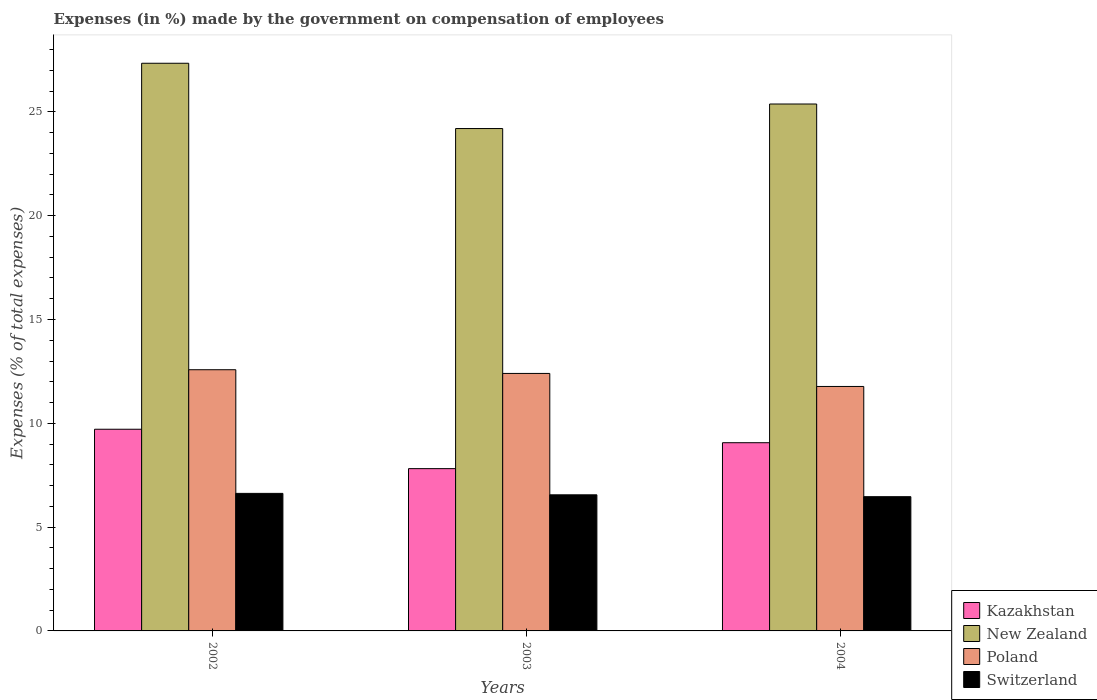Are the number of bars per tick equal to the number of legend labels?
Offer a terse response. Yes. Are the number of bars on each tick of the X-axis equal?
Ensure brevity in your answer.  Yes. How many bars are there on the 1st tick from the right?
Your answer should be very brief. 4. In how many cases, is the number of bars for a given year not equal to the number of legend labels?
Ensure brevity in your answer.  0. What is the percentage of expenses made by the government on compensation of employees in New Zealand in 2002?
Your response must be concise. 27.34. Across all years, what is the maximum percentage of expenses made by the government on compensation of employees in Switzerland?
Your answer should be compact. 6.62. Across all years, what is the minimum percentage of expenses made by the government on compensation of employees in Poland?
Your answer should be compact. 11.77. What is the total percentage of expenses made by the government on compensation of employees in New Zealand in the graph?
Offer a very short reply. 76.92. What is the difference between the percentage of expenses made by the government on compensation of employees in Kazakhstan in 2003 and that in 2004?
Make the answer very short. -1.25. What is the difference between the percentage of expenses made by the government on compensation of employees in Poland in 2002 and the percentage of expenses made by the government on compensation of employees in Kazakhstan in 2004?
Ensure brevity in your answer.  3.52. What is the average percentage of expenses made by the government on compensation of employees in Kazakhstan per year?
Provide a succinct answer. 8.87. In the year 2002, what is the difference between the percentage of expenses made by the government on compensation of employees in Kazakhstan and percentage of expenses made by the government on compensation of employees in Switzerland?
Make the answer very short. 3.09. In how many years, is the percentage of expenses made by the government on compensation of employees in Kazakhstan greater than 24 %?
Provide a succinct answer. 0. What is the ratio of the percentage of expenses made by the government on compensation of employees in Switzerland in 2002 to that in 2003?
Your response must be concise. 1.01. Is the difference between the percentage of expenses made by the government on compensation of employees in Kazakhstan in 2003 and 2004 greater than the difference between the percentage of expenses made by the government on compensation of employees in Switzerland in 2003 and 2004?
Offer a terse response. No. What is the difference between the highest and the second highest percentage of expenses made by the government on compensation of employees in Poland?
Provide a short and direct response. 0.18. What is the difference between the highest and the lowest percentage of expenses made by the government on compensation of employees in Kazakhstan?
Make the answer very short. 1.9. Is the sum of the percentage of expenses made by the government on compensation of employees in Kazakhstan in 2002 and 2003 greater than the maximum percentage of expenses made by the government on compensation of employees in Switzerland across all years?
Provide a succinct answer. Yes. What does the 1st bar from the left in 2002 represents?
Ensure brevity in your answer.  Kazakhstan. What does the 1st bar from the right in 2002 represents?
Ensure brevity in your answer.  Switzerland. Is it the case that in every year, the sum of the percentage of expenses made by the government on compensation of employees in New Zealand and percentage of expenses made by the government on compensation of employees in Kazakhstan is greater than the percentage of expenses made by the government on compensation of employees in Poland?
Give a very brief answer. Yes. How many years are there in the graph?
Ensure brevity in your answer.  3. What is the difference between two consecutive major ticks on the Y-axis?
Your answer should be very brief. 5. Are the values on the major ticks of Y-axis written in scientific E-notation?
Your answer should be compact. No. Does the graph contain grids?
Give a very brief answer. No. Where does the legend appear in the graph?
Make the answer very short. Bottom right. How are the legend labels stacked?
Your response must be concise. Vertical. What is the title of the graph?
Make the answer very short. Expenses (in %) made by the government on compensation of employees. Does "Singapore" appear as one of the legend labels in the graph?
Provide a short and direct response. No. What is the label or title of the X-axis?
Give a very brief answer. Years. What is the label or title of the Y-axis?
Ensure brevity in your answer.  Expenses (% of total expenses). What is the Expenses (% of total expenses) of Kazakhstan in 2002?
Keep it short and to the point. 9.71. What is the Expenses (% of total expenses) of New Zealand in 2002?
Give a very brief answer. 27.34. What is the Expenses (% of total expenses) in Poland in 2002?
Provide a succinct answer. 12.58. What is the Expenses (% of total expenses) of Switzerland in 2002?
Your answer should be very brief. 6.62. What is the Expenses (% of total expenses) of Kazakhstan in 2003?
Offer a very short reply. 7.82. What is the Expenses (% of total expenses) in New Zealand in 2003?
Provide a succinct answer. 24.2. What is the Expenses (% of total expenses) in Poland in 2003?
Keep it short and to the point. 12.4. What is the Expenses (% of total expenses) of Switzerland in 2003?
Ensure brevity in your answer.  6.56. What is the Expenses (% of total expenses) in Kazakhstan in 2004?
Your answer should be very brief. 9.07. What is the Expenses (% of total expenses) of New Zealand in 2004?
Make the answer very short. 25.38. What is the Expenses (% of total expenses) in Poland in 2004?
Ensure brevity in your answer.  11.77. What is the Expenses (% of total expenses) in Switzerland in 2004?
Your answer should be very brief. 6.47. Across all years, what is the maximum Expenses (% of total expenses) in Kazakhstan?
Your answer should be very brief. 9.71. Across all years, what is the maximum Expenses (% of total expenses) in New Zealand?
Offer a terse response. 27.34. Across all years, what is the maximum Expenses (% of total expenses) of Poland?
Your answer should be compact. 12.58. Across all years, what is the maximum Expenses (% of total expenses) in Switzerland?
Ensure brevity in your answer.  6.62. Across all years, what is the minimum Expenses (% of total expenses) of Kazakhstan?
Ensure brevity in your answer.  7.82. Across all years, what is the minimum Expenses (% of total expenses) of New Zealand?
Your answer should be compact. 24.2. Across all years, what is the minimum Expenses (% of total expenses) of Poland?
Provide a succinct answer. 11.77. Across all years, what is the minimum Expenses (% of total expenses) in Switzerland?
Provide a succinct answer. 6.47. What is the total Expenses (% of total expenses) of Kazakhstan in the graph?
Provide a succinct answer. 26.6. What is the total Expenses (% of total expenses) in New Zealand in the graph?
Offer a terse response. 76.92. What is the total Expenses (% of total expenses) in Poland in the graph?
Provide a succinct answer. 36.76. What is the total Expenses (% of total expenses) in Switzerland in the graph?
Provide a succinct answer. 19.65. What is the difference between the Expenses (% of total expenses) of Kazakhstan in 2002 and that in 2003?
Make the answer very short. 1.9. What is the difference between the Expenses (% of total expenses) of New Zealand in 2002 and that in 2003?
Your answer should be compact. 3.14. What is the difference between the Expenses (% of total expenses) in Poland in 2002 and that in 2003?
Provide a succinct answer. 0.18. What is the difference between the Expenses (% of total expenses) in Switzerland in 2002 and that in 2003?
Your response must be concise. 0.07. What is the difference between the Expenses (% of total expenses) of Kazakhstan in 2002 and that in 2004?
Your answer should be very brief. 0.65. What is the difference between the Expenses (% of total expenses) of New Zealand in 2002 and that in 2004?
Your answer should be compact. 1.96. What is the difference between the Expenses (% of total expenses) in Poland in 2002 and that in 2004?
Give a very brief answer. 0.81. What is the difference between the Expenses (% of total expenses) in Switzerland in 2002 and that in 2004?
Your answer should be compact. 0.16. What is the difference between the Expenses (% of total expenses) of Kazakhstan in 2003 and that in 2004?
Keep it short and to the point. -1.25. What is the difference between the Expenses (% of total expenses) of New Zealand in 2003 and that in 2004?
Provide a succinct answer. -1.18. What is the difference between the Expenses (% of total expenses) of Poland in 2003 and that in 2004?
Give a very brief answer. 0.63. What is the difference between the Expenses (% of total expenses) in Switzerland in 2003 and that in 2004?
Give a very brief answer. 0.09. What is the difference between the Expenses (% of total expenses) in Kazakhstan in 2002 and the Expenses (% of total expenses) in New Zealand in 2003?
Keep it short and to the point. -14.48. What is the difference between the Expenses (% of total expenses) of Kazakhstan in 2002 and the Expenses (% of total expenses) of Poland in 2003?
Provide a succinct answer. -2.69. What is the difference between the Expenses (% of total expenses) of Kazakhstan in 2002 and the Expenses (% of total expenses) of Switzerland in 2003?
Your answer should be compact. 3.16. What is the difference between the Expenses (% of total expenses) of New Zealand in 2002 and the Expenses (% of total expenses) of Poland in 2003?
Make the answer very short. 14.94. What is the difference between the Expenses (% of total expenses) in New Zealand in 2002 and the Expenses (% of total expenses) in Switzerland in 2003?
Your answer should be compact. 20.79. What is the difference between the Expenses (% of total expenses) in Poland in 2002 and the Expenses (% of total expenses) in Switzerland in 2003?
Ensure brevity in your answer.  6.02. What is the difference between the Expenses (% of total expenses) of Kazakhstan in 2002 and the Expenses (% of total expenses) of New Zealand in 2004?
Your response must be concise. -15.66. What is the difference between the Expenses (% of total expenses) in Kazakhstan in 2002 and the Expenses (% of total expenses) in Poland in 2004?
Offer a very short reply. -2.06. What is the difference between the Expenses (% of total expenses) of Kazakhstan in 2002 and the Expenses (% of total expenses) of Switzerland in 2004?
Make the answer very short. 3.25. What is the difference between the Expenses (% of total expenses) in New Zealand in 2002 and the Expenses (% of total expenses) in Poland in 2004?
Your answer should be compact. 15.57. What is the difference between the Expenses (% of total expenses) in New Zealand in 2002 and the Expenses (% of total expenses) in Switzerland in 2004?
Your answer should be very brief. 20.88. What is the difference between the Expenses (% of total expenses) in Poland in 2002 and the Expenses (% of total expenses) in Switzerland in 2004?
Your answer should be very brief. 6.11. What is the difference between the Expenses (% of total expenses) in Kazakhstan in 2003 and the Expenses (% of total expenses) in New Zealand in 2004?
Keep it short and to the point. -17.56. What is the difference between the Expenses (% of total expenses) in Kazakhstan in 2003 and the Expenses (% of total expenses) in Poland in 2004?
Give a very brief answer. -3.96. What is the difference between the Expenses (% of total expenses) in Kazakhstan in 2003 and the Expenses (% of total expenses) in Switzerland in 2004?
Give a very brief answer. 1.35. What is the difference between the Expenses (% of total expenses) in New Zealand in 2003 and the Expenses (% of total expenses) in Poland in 2004?
Your answer should be compact. 12.42. What is the difference between the Expenses (% of total expenses) in New Zealand in 2003 and the Expenses (% of total expenses) in Switzerland in 2004?
Give a very brief answer. 17.73. What is the difference between the Expenses (% of total expenses) in Poland in 2003 and the Expenses (% of total expenses) in Switzerland in 2004?
Make the answer very short. 5.94. What is the average Expenses (% of total expenses) in Kazakhstan per year?
Provide a succinct answer. 8.87. What is the average Expenses (% of total expenses) in New Zealand per year?
Your answer should be very brief. 25.64. What is the average Expenses (% of total expenses) in Poland per year?
Your response must be concise. 12.25. What is the average Expenses (% of total expenses) of Switzerland per year?
Your answer should be compact. 6.55. In the year 2002, what is the difference between the Expenses (% of total expenses) of Kazakhstan and Expenses (% of total expenses) of New Zealand?
Provide a succinct answer. -17.63. In the year 2002, what is the difference between the Expenses (% of total expenses) of Kazakhstan and Expenses (% of total expenses) of Poland?
Ensure brevity in your answer.  -2.87. In the year 2002, what is the difference between the Expenses (% of total expenses) in Kazakhstan and Expenses (% of total expenses) in Switzerland?
Make the answer very short. 3.09. In the year 2002, what is the difference between the Expenses (% of total expenses) of New Zealand and Expenses (% of total expenses) of Poland?
Provide a short and direct response. 14.76. In the year 2002, what is the difference between the Expenses (% of total expenses) in New Zealand and Expenses (% of total expenses) in Switzerland?
Ensure brevity in your answer.  20.72. In the year 2002, what is the difference between the Expenses (% of total expenses) in Poland and Expenses (% of total expenses) in Switzerland?
Provide a short and direct response. 5.96. In the year 2003, what is the difference between the Expenses (% of total expenses) of Kazakhstan and Expenses (% of total expenses) of New Zealand?
Offer a terse response. -16.38. In the year 2003, what is the difference between the Expenses (% of total expenses) of Kazakhstan and Expenses (% of total expenses) of Poland?
Your answer should be very brief. -4.58. In the year 2003, what is the difference between the Expenses (% of total expenses) in Kazakhstan and Expenses (% of total expenses) in Switzerland?
Your answer should be compact. 1.26. In the year 2003, what is the difference between the Expenses (% of total expenses) of New Zealand and Expenses (% of total expenses) of Poland?
Make the answer very short. 11.79. In the year 2003, what is the difference between the Expenses (% of total expenses) in New Zealand and Expenses (% of total expenses) in Switzerland?
Make the answer very short. 17.64. In the year 2003, what is the difference between the Expenses (% of total expenses) of Poland and Expenses (% of total expenses) of Switzerland?
Your answer should be very brief. 5.85. In the year 2004, what is the difference between the Expenses (% of total expenses) of Kazakhstan and Expenses (% of total expenses) of New Zealand?
Your response must be concise. -16.31. In the year 2004, what is the difference between the Expenses (% of total expenses) in Kazakhstan and Expenses (% of total expenses) in Poland?
Your answer should be compact. -2.71. In the year 2004, what is the difference between the Expenses (% of total expenses) in Kazakhstan and Expenses (% of total expenses) in Switzerland?
Offer a terse response. 2.6. In the year 2004, what is the difference between the Expenses (% of total expenses) in New Zealand and Expenses (% of total expenses) in Poland?
Ensure brevity in your answer.  13.6. In the year 2004, what is the difference between the Expenses (% of total expenses) in New Zealand and Expenses (% of total expenses) in Switzerland?
Keep it short and to the point. 18.91. In the year 2004, what is the difference between the Expenses (% of total expenses) in Poland and Expenses (% of total expenses) in Switzerland?
Offer a terse response. 5.31. What is the ratio of the Expenses (% of total expenses) in Kazakhstan in 2002 to that in 2003?
Offer a very short reply. 1.24. What is the ratio of the Expenses (% of total expenses) of New Zealand in 2002 to that in 2003?
Ensure brevity in your answer.  1.13. What is the ratio of the Expenses (% of total expenses) in Poland in 2002 to that in 2003?
Provide a succinct answer. 1.01. What is the ratio of the Expenses (% of total expenses) in Switzerland in 2002 to that in 2003?
Give a very brief answer. 1.01. What is the ratio of the Expenses (% of total expenses) of Kazakhstan in 2002 to that in 2004?
Offer a very short reply. 1.07. What is the ratio of the Expenses (% of total expenses) in New Zealand in 2002 to that in 2004?
Your response must be concise. 1.08. What is the ratio of the Expenses (% of total expenses) of Poland in 2002 to that in 2004?
Offer a terse response. 1.07. What is the ratio of the Expenses (% of total expenses) of Switzerland in 2002 to that in 2004?
Your response must be concise. 1.02. What is the ratio of the Expenses (% of total expenses) in Kazakhstan in 2003 to that in 2004?
Ensure brevity in your answer.  0.86. What is the ratio of the Expenses (% of total expenses) in New Zealand in 2003 to that in 2004?
Keep it short and to the point. 0.95. What is the ratio of the Expenses (% of total expenses) of Poland in 2003 to that in 2004?
Your response must be concise. 1.05. What is the ratio of the Expenses (% of total expenses) of Switzerland in 2003 to that in 2004?
Offer a terse response. 1.01. What is the difference between the highest and the second highest Expenses (% of total expenses) in Kazakhstan?
Provide a short and direct response. 0.65. What is the difference between the highest and the second highest Expenses (% of total expenses) in New Zealand?
Make the answer very short. 1.96. What is the difference between the highest and the second highest Expenses (% of total expenses) in Poland?
Offer a very short reply. 0.18. What is the difference between the highest and the second highest Expenses (% of total expenses) of Switzerland?
Offer a terse response. 0.07. What is the difference between the highest and the lowest Expenses (% of total expenses) of Kazakhstan?
Your response must be concise. 1.9. What is the difference between the highest and the lowest Expenses (% of total expenses) in New Zealand?
Ensure brevity in your answer.  3.14. What is the difference between the highest and the lowest Expenses (% of total expenses) of Poland?
Provide a short and direct response. 0.81. What is the difference between the highest and the lowest Expenses (% of total expenses) of Switzerland?
Offer a very short reply. 0.16. 